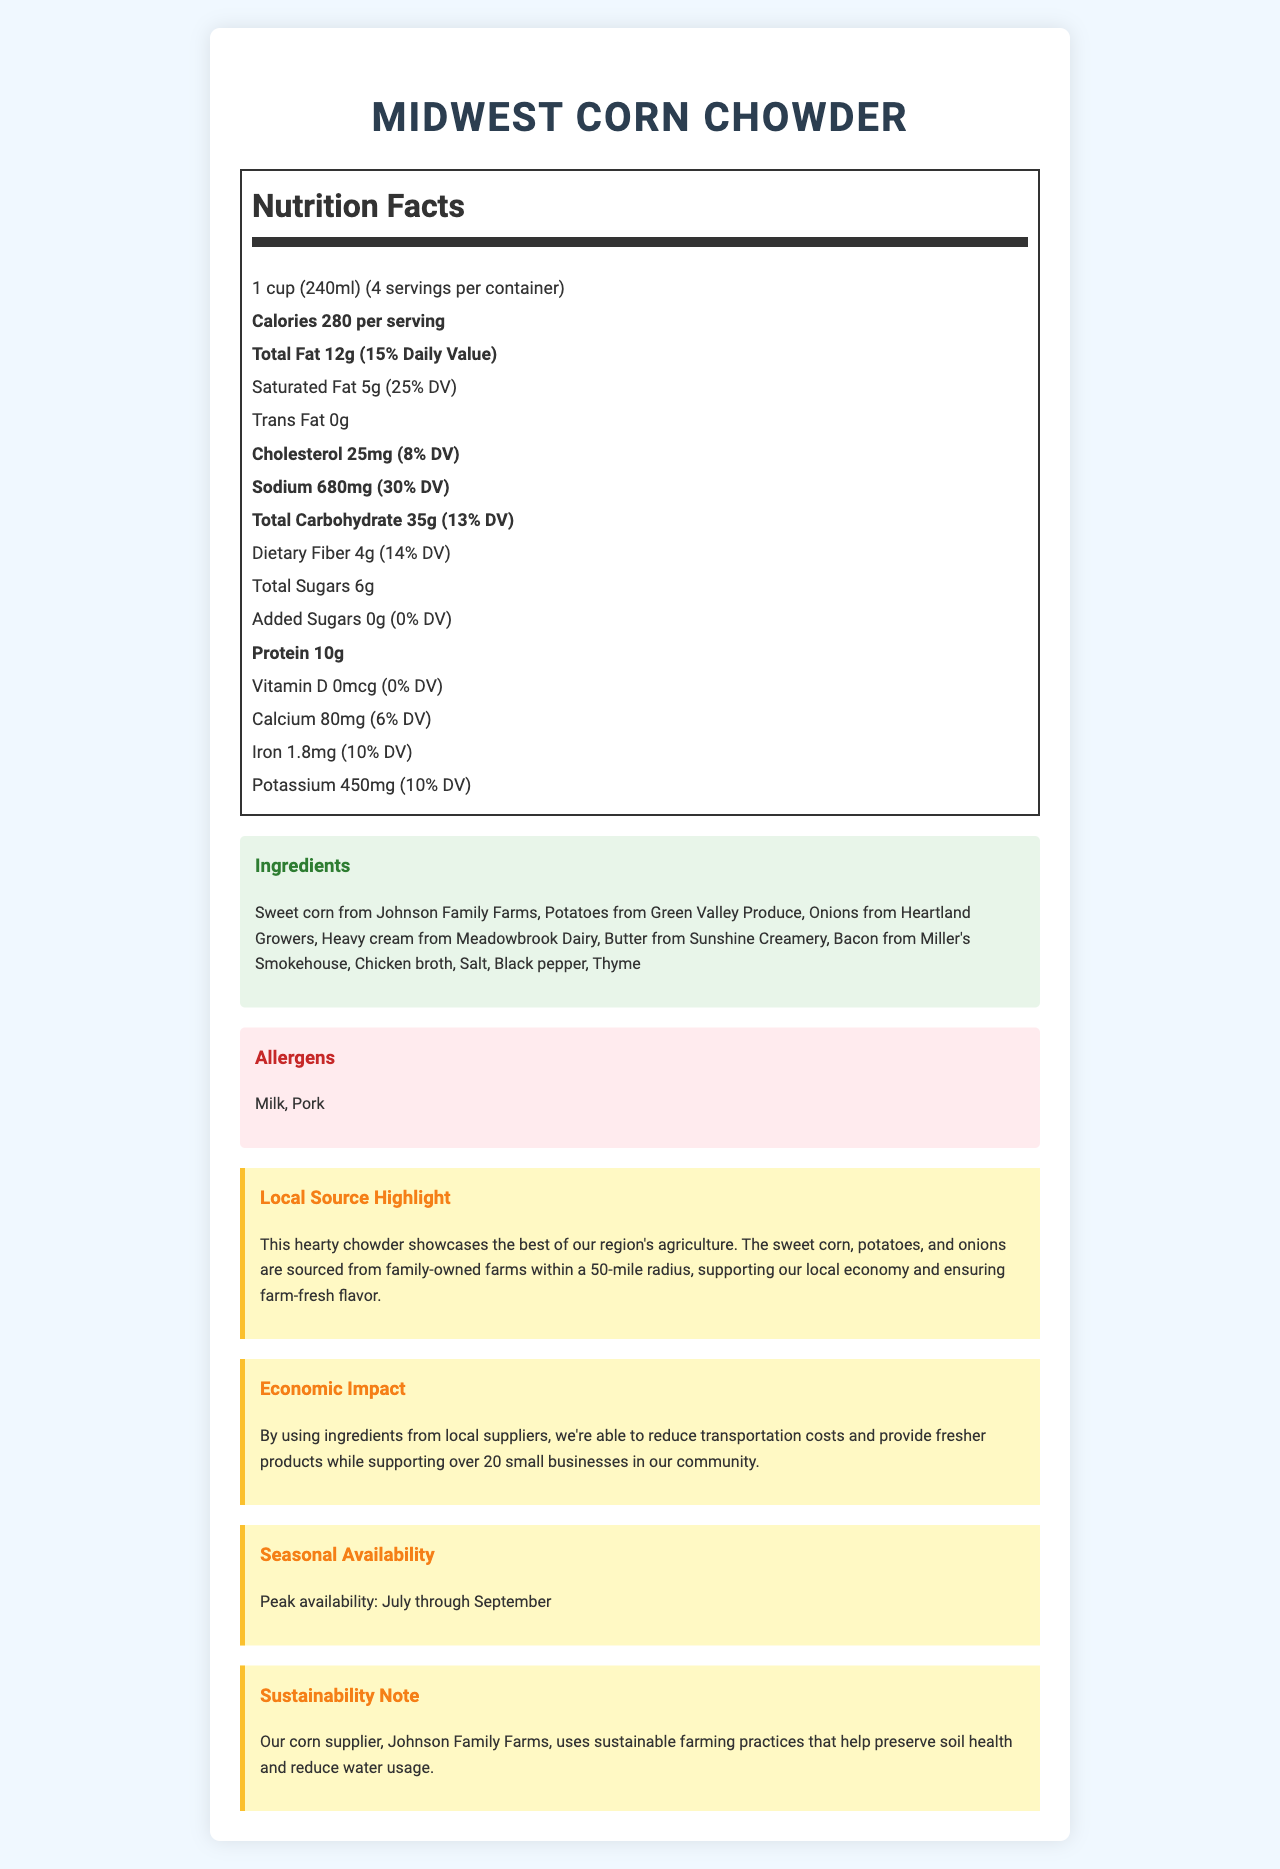what is the serving size? The serving size is clearly stated at the top of the Nutrition Facts section as "1 cup (240ml)".
Answer: 1 cup (240ml) how many calories are there per serving? The document lists 280 calories per serving in the bold text under the nutrition facts.
Answer: 280 what percentage of the daily value is the total fat content? The total fat content is specified as 15% of the daily value in the nutrition facts.
Answer: 15% name two ingredients in the Midwest Corn Chowder. The ingredients section lists these ingredients clearly.
Answer: Sweet corn from Johnson Family Farms, Potatoes from Green Valley Produce what are the allergens present in the chowder? The allergens are listed in a special allergens section.
Answer: Milk, Pork how many servings are there per container? The servings per container are stated as 4 in the Nutrition Facts section.
Answer: 4 how much dietary fiber is there in one serving? The nutritional label lists 4g of dietary fiber per serving.
Answer: 4g where is the corn in the chowder sourced from? The local source highlight mentions that the sweet corn is from Johnson Family Farms.
Answer: Johnson Family Farms is there any trans fat in the chowder? The Nutrition Facts label indicates "Trans Fat 0g", which means there is no trans fat.
Answer: No how much protein is in each serving of the chowder? The nutrition label indicates that each serving contains 10g of protein.
Answer: 10g which ingredient comes from Meadowbrook Dairy? A. Onions B. Heavy cream C. Bacon D. Potatoes The ingredients list specifies that the heavy cream comes from Meadowbrook Dairy.
Answer: B. Heavy cream what percentage of the daily value for sodium does one serving provide? A. 8% B. 10% C. 25% D. 30% The document states that sodium is 680mg per serving, which is 30% of the daily value.
Answer: D. 30% does the chowder contain added sugars? The nutrition label states "Added Sugars 0g", indicating no added sugars.
Answer: No describe the main idea of the document. The document contains sections on nutrition facts, ingredients, allergens, local sourcing, economic impact, seasonal availability, and sustainability, emphasizing the use of locally sourced ingredients and their benefits.
Answer: The document provides detailed nutrition facts and ingredient information for Midwest Corn Chowder, highlighting the use of local ingredients to support regional agriculture and small businesses. It also touches on the economic impact and sustainability practices of local suppliers. how many small businesses are supported through ingredient sourcing? The economic impact section states that the chowder's ingredients support over 20 small businesses.
Answer: Over 20 which of the following is not mentioned as an ingredient? A. Salt B. Chicken broth C. Carrots D. Black pepper The ingredients list does not mention carrots among the included items.
Answer: C. Carrots when is the peak availability for the chowder? The seasonal availability section indicates peak availability in July through September.
Answer: July through September are sustainable farming practices used by the corn supplier? The sustainability note mentions that Johnson Family Farms uses sustainable farming practices.
Answer: Yes how much calcium is there per serving? The nutrition facts label states that there is 80mg of calcium per serving.
Answer: 80mg how many grams of protein are in the entire container of chowder? Since there are 4 servings per container, and each serving has 10g of protein, the total is 4 x 10g = 40g.
Answer: 40g when was the chowder first produced? The document does not provide any information about the production date of the chowder.
Answer: Cannot be determined 